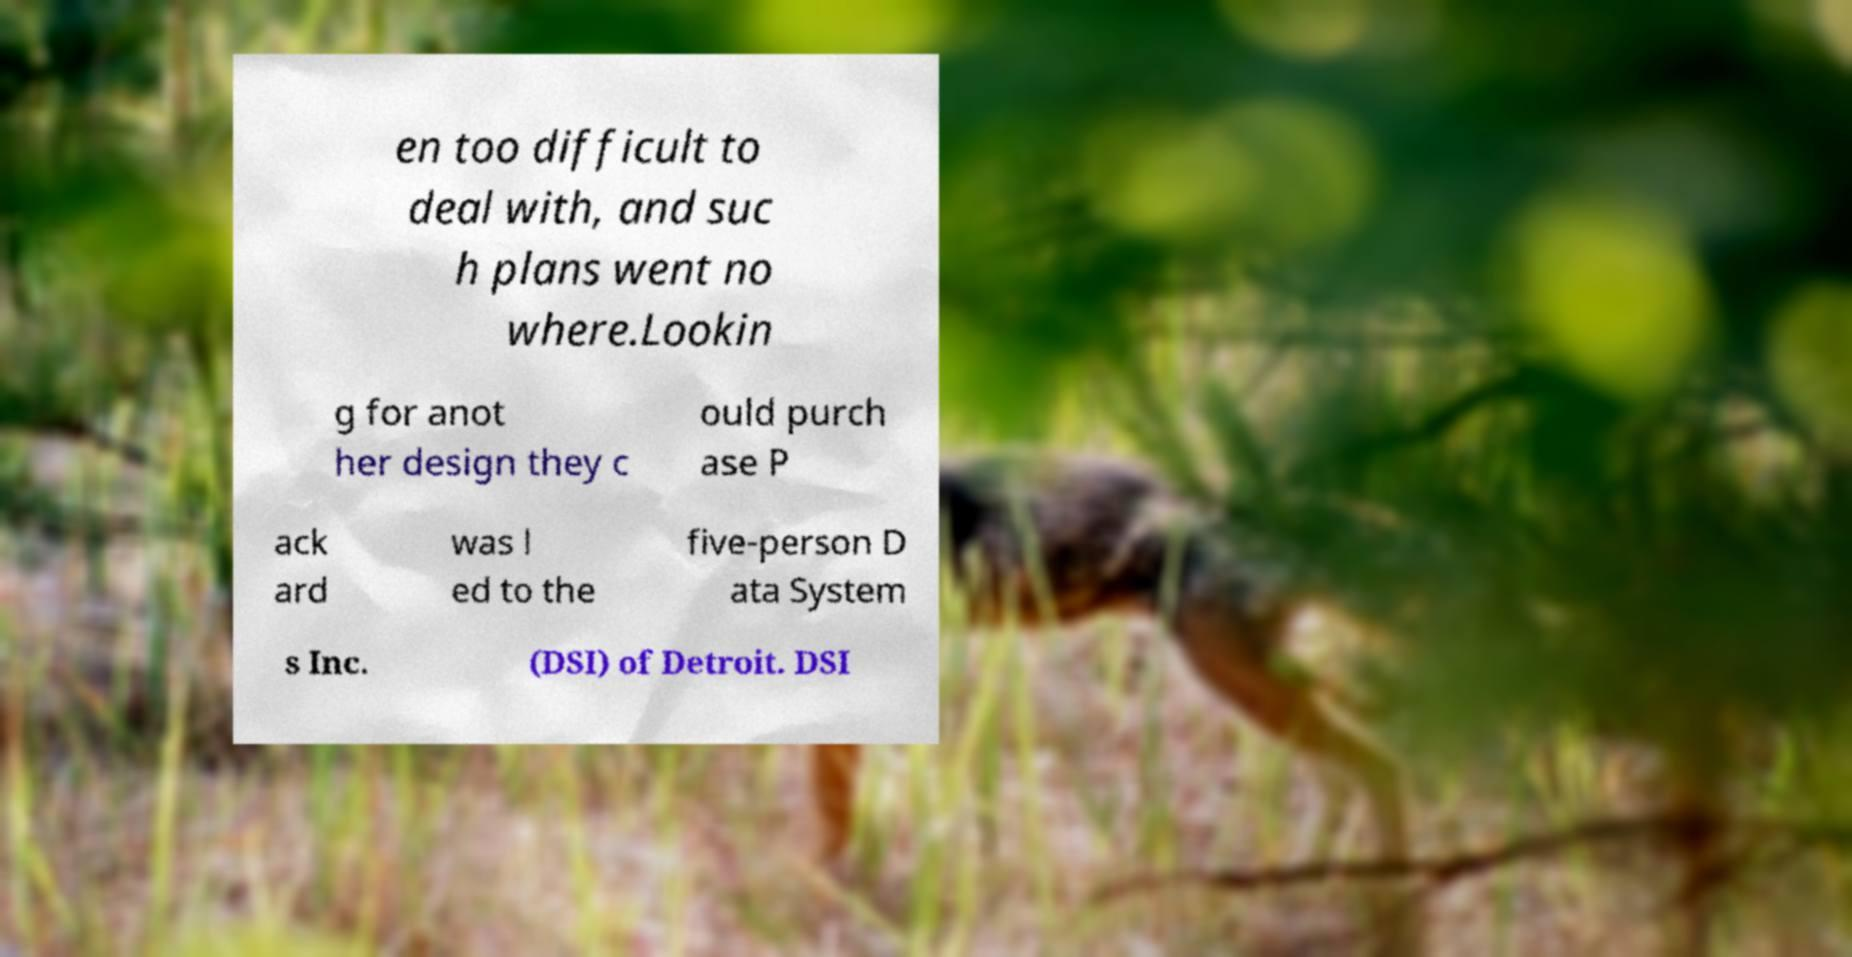Can you read and provide the text displayed in the image?This photo seems to have some interesting text. Can you extract and type it out for me? en too difficult to deal with, and suc h plans went no where.Lookin g for anot her design they c ould purch ase P ack ard was l ed to the five-person D ata System s Inc. (DSI) of Detroit. DSI 